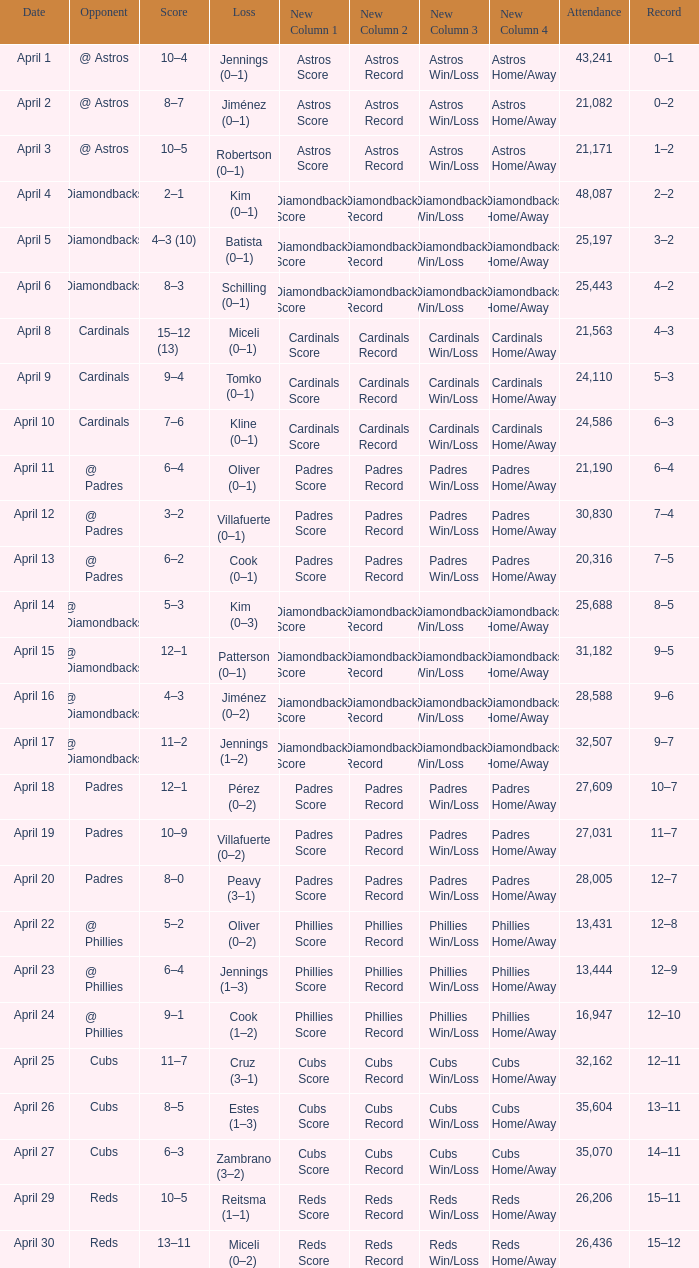Who is the opponent on april 16? @ Diamondbacks. Parse the table in full. {'header': ['Date', 'Opponent', 'Score', 'Loss', 'New Column 1', 'New Column 2', 'New Column 3', 'New Column 4', 'Attendance', 'Record'], 'rows': [['April 1', '@ Astros', '10–4', 'Jennings (0–1)', 'Astros Score', 'Astros Record', 'Astros Win/Loss', 'Astros Home/Away', '43,241', '0–1'], ['April 2', '@ Astros', '8–7', 'Jiménez (0–1)', 'Astros Score', 'Astros Record', 'Astros Win/Loss', 'Astros Home/Away', '21,082', '0–2'], ['April 3', '@ Astros', '10–5', 'Robertson (0–1)', 'Astros Score', 'Astros Record', 'Astros Win/Loss', 'Astros Home/Away', '21,171', '1–2'], ['April 4', 'Diamondbacks', '2–1', 'Kim (0–1)', 'Diamondbacks Score', 'Diamondbacks Record', 'Diamondbacks Win/Loss', 'Diamondbacks Home/Away', '48,087', '2–2'], ['April 5', 'Diamondbacks', '4–3 (10)', 'Batista (0–1)', 'Diamondbacks Score', 'Diamondbacks Record', 'Diamondbacks Win/Loss', 'Diamondbacks Home/Away', '25,197', '3–2'], ['April 6', 'Diamondbacks', '8–3', 'Schilling (0–1)', 'Diamondbacks Score', 'Diamondbacks Record', 'Diamondbacks Win/Loss', 'Diamondbacks Home/Away', '25,443', '4–2'], ['April 8', 'Cardinals', '15–12 (13)', 'Miceli (0–1)', 'Cardinals Score', 'Cardinals Record', 'Cardinals Win/Loss', 'Cardinals Home/Away', '21,563', '4–3'], ['April 9', 'Cardinals', '9–4', 'Tomko (0–1)', 'Cardinals Score', 'Cardinals Record', 'Cardinals Win/Loss', 'Cardinals Home/Away', '24,110', '5–3'], ['April 10', 'Cardinals', '7–6', 'Kline (0–1)', 'Cardinals Score', 'Cardinals Record', 'Cardinals Win/Loss', 'Cardinals Home/Away', '24,586', '6–3'], ['April 11', '@ Padres', '6–4', 'Oliver (0–1)', 'Padres Score', 'Padres Record', 'Padres Win/Loss', 'Padres Home/Away', '21,190', '6–4'], ['April 12', '@ Padres', '3–2', 'Villafuerte (0–1)', 'Padres Score', 'Padres Record', 'Padres Win/Loss', 'Padres Home/Away', '30,830', '7–4'], ['April 13', '@ Padres', '6–2', 'Cook (0–1)', 'Padres Score', 'Padres Record', 'Padres Win/Loss', 'Padres Home/Away', '20,316', '7–5'], ['April 14', '@ Diamondbacks', '5–3', 'Kim (0–3)', 'Diamondbacks Score', 'Diamondbacks Record', 'Diamondbacks Win/Loss', 'Diamondbacks Home/Away', '25,688', '8–5'], ['April 15', '@ Diamondbacks', '12–1', 'Patterson (0–1)', 'Diamondbacks Score', 'Diamondbacks Record', 'Diamondbacks Win/Loss', 'Diamondbacks Home/Away', '31,182', '9–5'], ['April 16', '@ Diamondbacks', '4–3', 'Jiménez (0–2)', 'Diamondbacks Score', 'Diamondbacks Record', 'Diamondbacks Win/Loss', 'Diamondbacks Home/Away', '28,588', '9–6'], ['April 17', '@ Diamondbacks', '11–2', 'Jennings (1–2)', 'Diamondbacks Score', 'Diamondbacks Record', 'Diamondbacks Win/Loss', 'Diamondbacks Home/Away', '32,507', '9–7'], ['April 18', 'Padres', '12–1', 'Pérez (0–2)', 'Padres Score', 'Padres Record', 'Padres Win/Loss', 'Padres Home/Away', '27,609', '10–7'], ['April 19', 'Padres', '10–9', 'Villafuerte (0–2)', 'Padres Score', 'Padres Record', 'Padres Win/Loss', 'Padres Home/Away', '27,031', '11–7'], ['April 20', 'Padres', '8–0', 'Peavy (3–1)', 'Padres Score', 'Padres Record', 'Padres Win/Loss', 'Padres Home/Away', '28,005', '12–7'], ['April 22', '@ Phillies', '5–2', 'Oliver (0–2)', 'Phillies Score', 'Phillies Record', 'Phillies Win/Loss', 'Phillies Home/Away', '13,431', '12–8'], ['April 23', '@ Phillies', '6–4', 'Jennings (1–3)', 'Phillies Score', 'Phillies Record', 'Phillies Win/Loss', 'Phillies Home/Away', '13,444', '12–9'], ['April 24', '@ Phillies', '9–1', 'Cook (1–2)', 'Phillies Score', 'Phillies Record', 'Phillies Win/Loss', 'Phillies Home/Away', '16,947', '12–10'], ['April 25', 'Cubs', '11–7', 'Cruz (3–1)', 'Cubs Score', 'Cubs Record', 'Cubs Win/Loss', 'Cubs Home/Away', '32,162', '12–11'], ['April 26', 'Cubs', '8–5', 'Estes (1–3)', 'Cubs Score', 'Cubs Record', 'Cubs Win/Loss', 'Cubs Home/Away', '35,604', '13–11'], ['April 27', 'Cubs', '6–3', 'Zambrano (3–2)', 'Cubs Score', 'Cubs Record', 'Cubs Win/Loss', 'Cubs Home/Away', '35,070', '14–11'], ['April 29', 'Reds', '10–5', 'Reitsma (1–1)', 'Reds Score', 'Reds Record', 'Reds Win/Loss', 'Reds Home/Away', '26,206', '15–11'], ['April 30', 'Reds', '13–11', 'Miceli (0–2)', 'Reds Score', 'Reds Record', 'Reds Win/Loss', 'Reds Home/Away', '26,436', '15–12']]} 